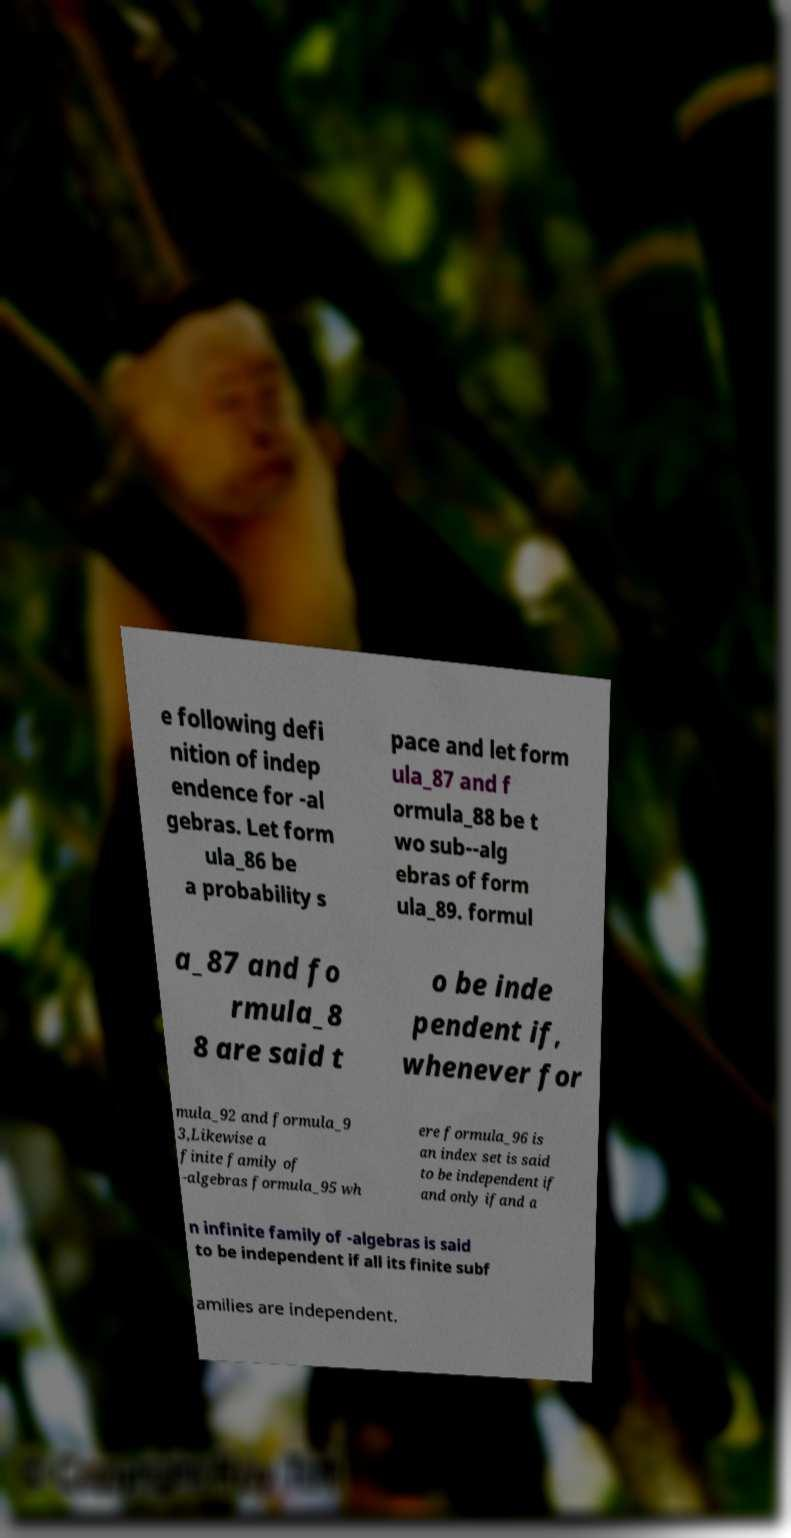For documentation purposes, I need the text within this image transcribed. Could you provide that? e following defi nition of indep endence for -al gebras. Let form ula_86 be a probability s pace and let form ula_87 and f ormula_88 be t wo sub--alg ebras of form ula_89. formul a_87 and fo rmula_8 8 are said t o be inde pendent if, whenever for mula_92 and formula_9 3,Likewise a finite family of -algebras formula_95 wh ere formula_96 is an index set is said to be independent if and only ifand a n infinite family of -algebras is said to be independent if all its finite subf amilies are independent. 